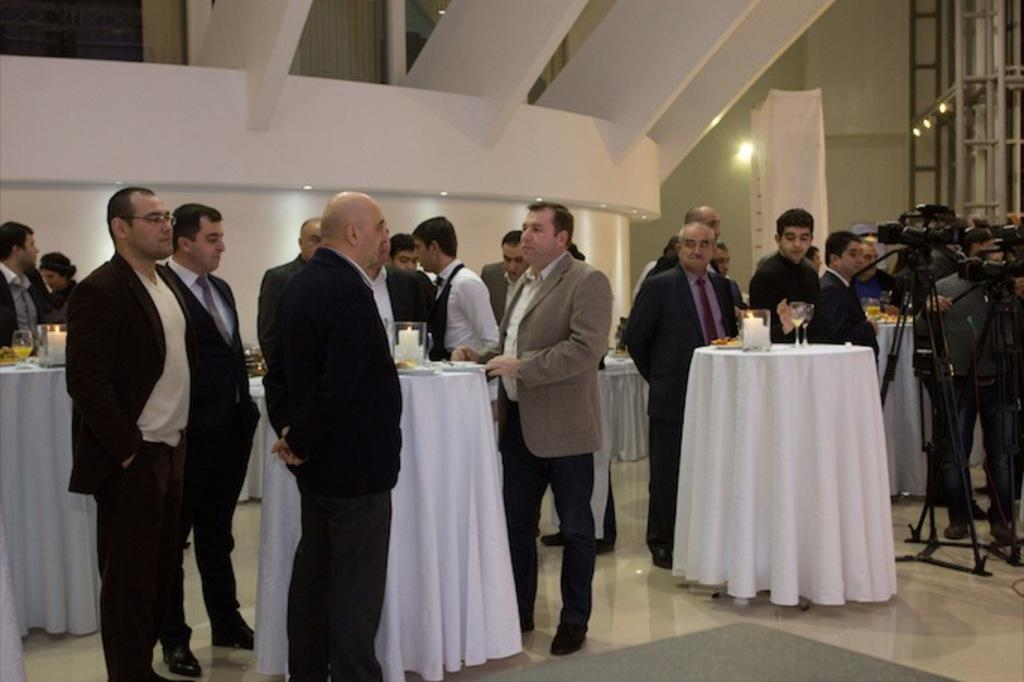What type of furniture is present in the image? There are tables in the image. Where are the videographers located in the image? The videographers are on the right side of the image. What are the people doing in the image? The people are standing on the tables. What items can be seen on the tables? There are candles, glasses, and plates on the tables. What type of rake is being used by the people standing on the tables? There is no rake present in the image; the people are standing on tables with candles, glasses, and plates. What type of approval is being given by the videographers in the image? There is no indication of approval or any related activity in the image; the videographers are simply located on the right side of the image. 